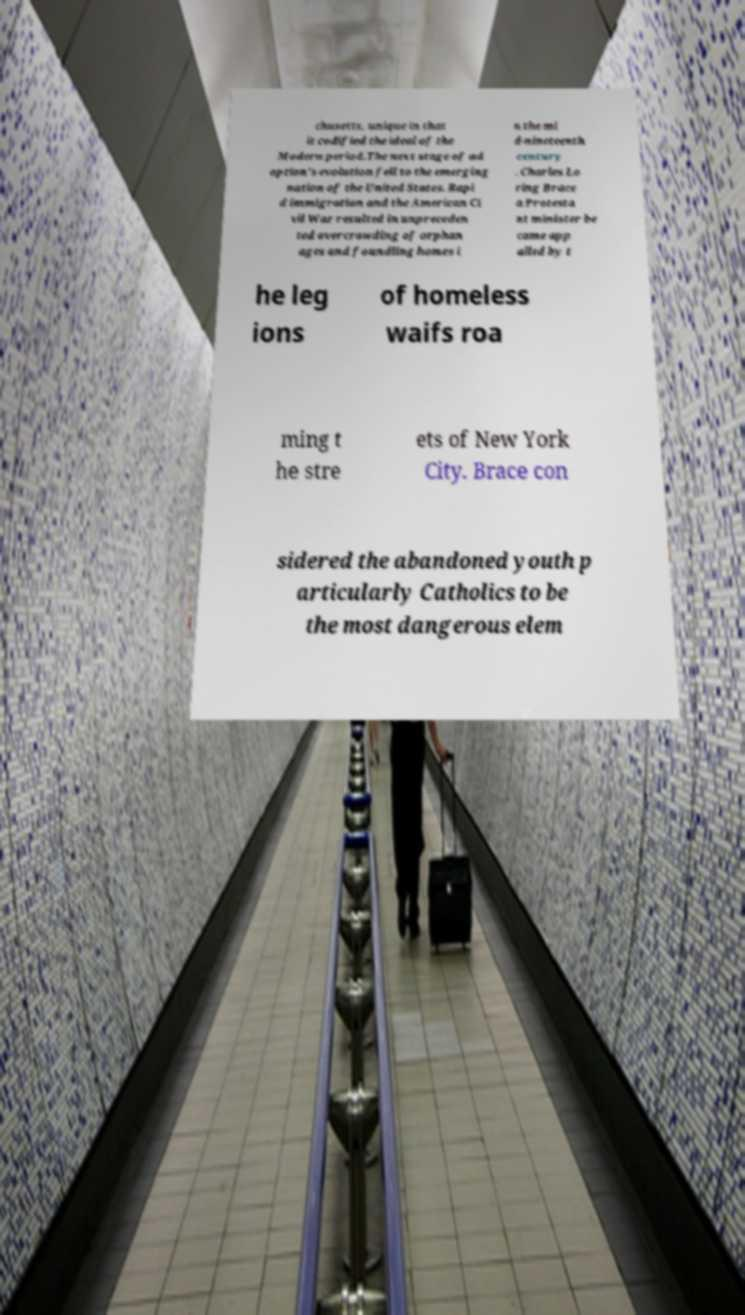Could you extract and type out the text from this image? chusetts, unique in that it codified the ideal of the Modern period.The next stage of ad option's evolution fell to the emerging nation of the United States. Rapi d immigration and the American Ci vil War resulted in unpreceden ted overcrowding of orphan ages and foundling homes i n the mi d-nineteenth century . Charles Lo ring Brace a Protesta nt minister be came app alled by t he leg ions of homeless waifs roa ming t he stre ets of New York City. Brace con sidered the abandoned youth p articularly Catholics to be the most dangerous elem 